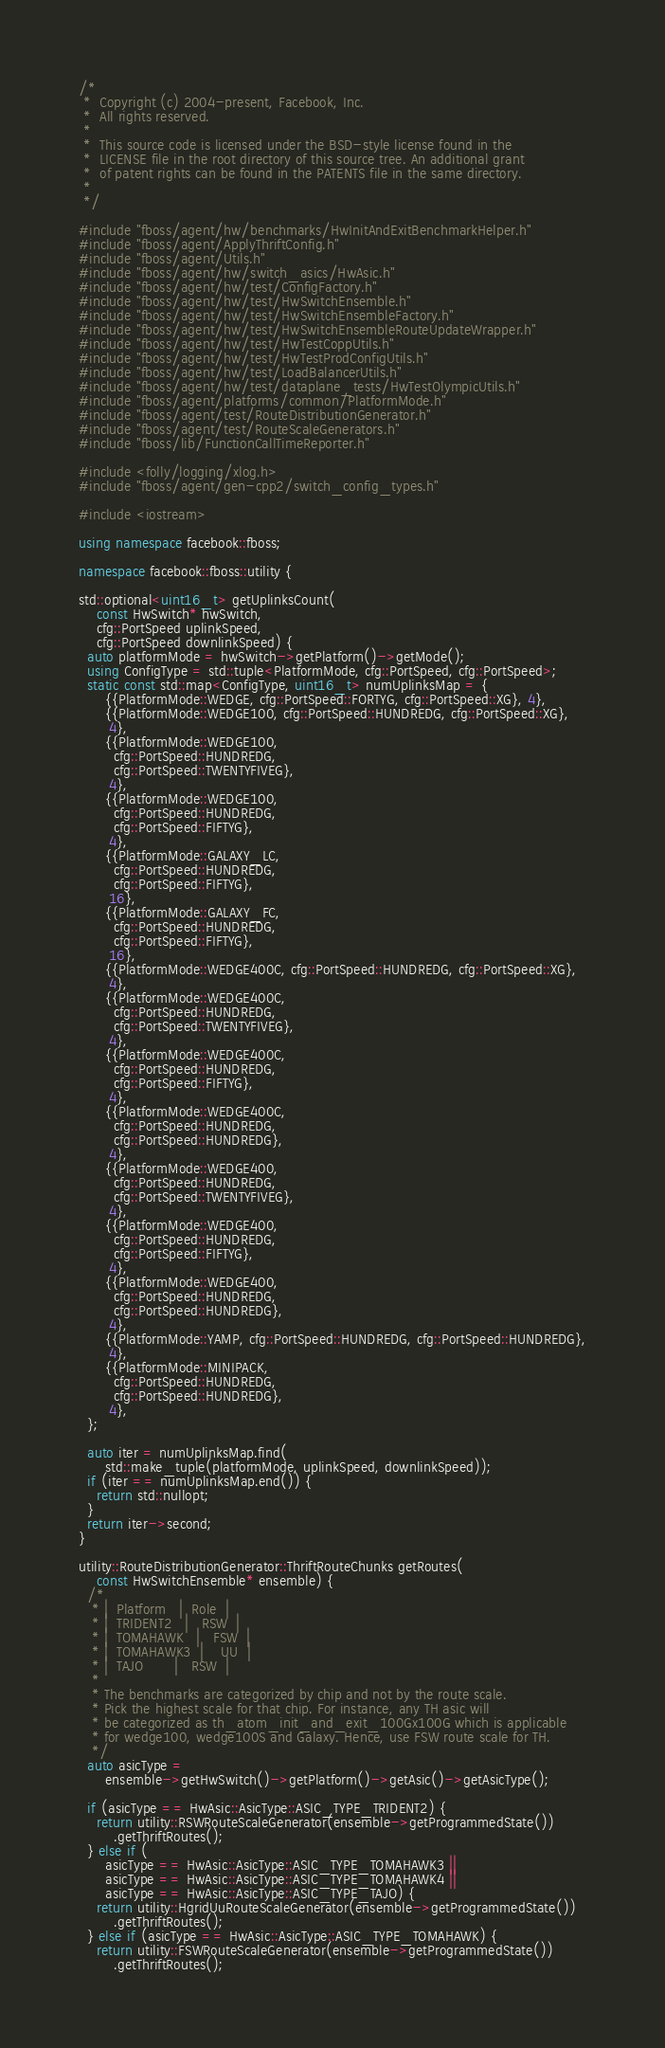Convert code to text. <code><loc_0><loc_0><loc_500><loc_500><_C++_>/*
 *  Copyright (c) 2004-present, Facebook, Inc.
 *  All rights reserved.
 *
 *  This source code is licensed under the BSD-style license found in the
 *  LICENSE file in the root directory of this source tree. An additional grant
 *  of patent rights can be found in the PATENTS file in the same directory.
 *
 */

#include "fboss/agent/hw/benchmarks/HwInitAndExitBenchmarkHelper.h"
#include "fboss/agent/ApplyThriftConfig.h"
#include "fboss/agent/Utils.h"
#include "fboss/agent/hw/switch_asics/HwAsic.h"
#include "fboss/agent/hw/test/ConfigFactory.h"
#include "fboss/agent/hw/test/HwSwitchEnsemble.h"
#include "fboss/agent/hw/test/HwSwitchEnsembleFactory.h"
#include "fboss/agent/hw/test/HwSwitchEnsembleRouteUpdateWrapper.h"
#include "fboss/agent/hw/test/HwTestCoppUtils.h"
#include "fboss/agent/hw/test/HwTestProdConfigUtils.h"
#include "fboss/agent/hw/test/LoadBalancerUtils.h"
#include "fboss/agent/hw/test/dataplane_tests/HwTestOlympicUtils.h"
#include "fboss/agent/platforms/common/PlatformMode.h"
#include "fboss/agent/test/RouteDistributionGenerator.h"
#include "fboss/agent/test/RouteScaleGenerators.h"
#include "fboss/lib/FunctionCallTimeReporter.h"

#include <folly/logging/xlog.h>
#include "fboss/agent/gen-cpp2/switch_config_types.h"

#include <iostream>

using namespace facebook::fboss;

namespace facebook::fboss::utility {

std::optional<uint16_t> getUplinksCount(
    const HwSwitch* hwSwitch,
    cfg::PortSpeed uplinkSpeed,
    cfg::PortSpeed downlinkSpeed) {
  auto platformMode = hwSwitch->getPlatform()->getMode();
  using ConfigType = std::tuple<PlatformMode, cfg::PortSpeed, cfg::PortSpeed>;
  static const std::map<ConfigType, uint16_t> numUplinksMap = {
      {{PlatformMode::WEDGE, cfg::PortSpeed::FORTYG, cfg::PortSpeed::XG}, 4},
      {{PlatformMode::WEDGE100, cfg::PortSpeed::HUNDREDG, cfg::PortSpeed::XG},
       4},
      {{PlatformMode::WEDGE100,
        cfg::PortSpeed::HUNDREDG,
        cfg::PortSpeed::TWENTYFIVEG},
       4},
      {{PlatformMode::WEDGE100,
        cfg::PortSpeed::HUNDREDG,
        cfg::PortSpeed::FIFTYG},
       4},
      {{PlatformMode::GALAXY_LC,
        cfg::PortSpeed::HUNDREDG,
        cfg::PortSpeed::FIFTYG},
       16},
      {{PlatformMode::GALAXY_FC,
        cfg::PortSpeed::HUNDREDG,
        cfg::PortSpeed::FIFTYG},
       16},
      {{PlatformMode::WEDGE400C, cfg::PortSpeed::HUNDREDG, cfg::PortSpeed::XG},
       4},
      {{PlatformMode::WEDGE400C,
        cfg::PortSpeed::HUNDREDG,
        cfg::PortSpeed::TWENTYFIVEG},
       4},
      {{PlatformMode::WEDGE400C,
        cfg::PortSpeed::HUNDREDG,
        cfg::PortSpeed::FIFTYG},
       4},
      {{PlatformMode::WEDGE400C,
        cfg::PortSpeed::HUNDREDG,
        cfg::PortSpeed::HUNDREDG},
       4},
      {{PlatformMode::WEDGE400,
        cfg::PortSpeed::HUNDREDG,
        cfg::PortSpeed::TWENTYFIVEG},
       4},
      {{PlatformMode::WEDGE400,
        cfg::PortSpeed::HUNDREDG,
        cfg::PortSpeed::FIFTYG},
       4},
      {{PlatformMode::WEDGE400,
        cfg::PortSpeed::HUNDREDG,
        cfg::PortSpeed::HUNDREDG},
       4},
      {{PlatformMode::YAMP, cfg::PortSpeed::HUNDREDG, cfg::PortSpeed::HUNDREDG},
       4},
      {{PlatformMode::MINIPACK,
        cfg::PortSpeed::HUNDREDG,
        cfg::PortSpeed::HUNDREDG},
       4},
  };

  auto iter = numUplinksMap.find(
      std::make_tuple(platformMode, uplinkSpeed, downlinkSpeed));
  if (iter == numUplinksMap.end()) {
    return std::nullopt;
  }
  return iter->second;
}

utility::RouteDistributionGenerator::ThriftRouteChunks getRoutes(
    const HwSwitchEnsemble* ensemble) {
  /*
   * |  Platform   |  Role  |
   * |  TRIDENT2   |   RSW  |
   * |  TOMAHAWK   |   FSW  |
   * |  TOMAHAWK3  |    UU  |
   * |  TAJO       |   RSW  |
   *
   * The benchmarks are categorized by chip and not by the route scale.
   * Pick the highest scale for that chip. For instance, any TH asic will
   * be categorized as th_atom_init_and_exit_100Gx100G which is applicable
   * for wedge100, wedge100S and Galaxy. Hence, use FSW route scale for TH.
   */
  auto asicType =
      ensemble->getHwSwitch()->getPlatform()->getAsic()->getAsicType();

  if (asicType == HwAsic::AsicType::ASIC_TYPE_TRIDENT2) {
    return utility::RSWRouteScaleGenerator(ensemble->getProgrammedState())
        .getThriftRoutes();
  } else if (
      asicType == HwAsic::AsicType::ASIC_TYPE_TOMAHAWK3 ||
      asicType == HwAsic::AsicType::ASIC_TYPE_TOMAHAWK4 ||
      asicType == HwAsic::AsicType::ASIC_TYPE_TAJO) {
    return utility::HgridUuRouteScaleGenerator(ensemble->getProgrammedState())
        .getThriftRoutes();
  } else if (asicType == HwAsic::AsicType::ASIC_TYPE_TOMAHAWK) {
    return utility::FSWRouteScaleGenerator(ensemble->getProgrammedState())
        .getThriftRoutes();</code> 